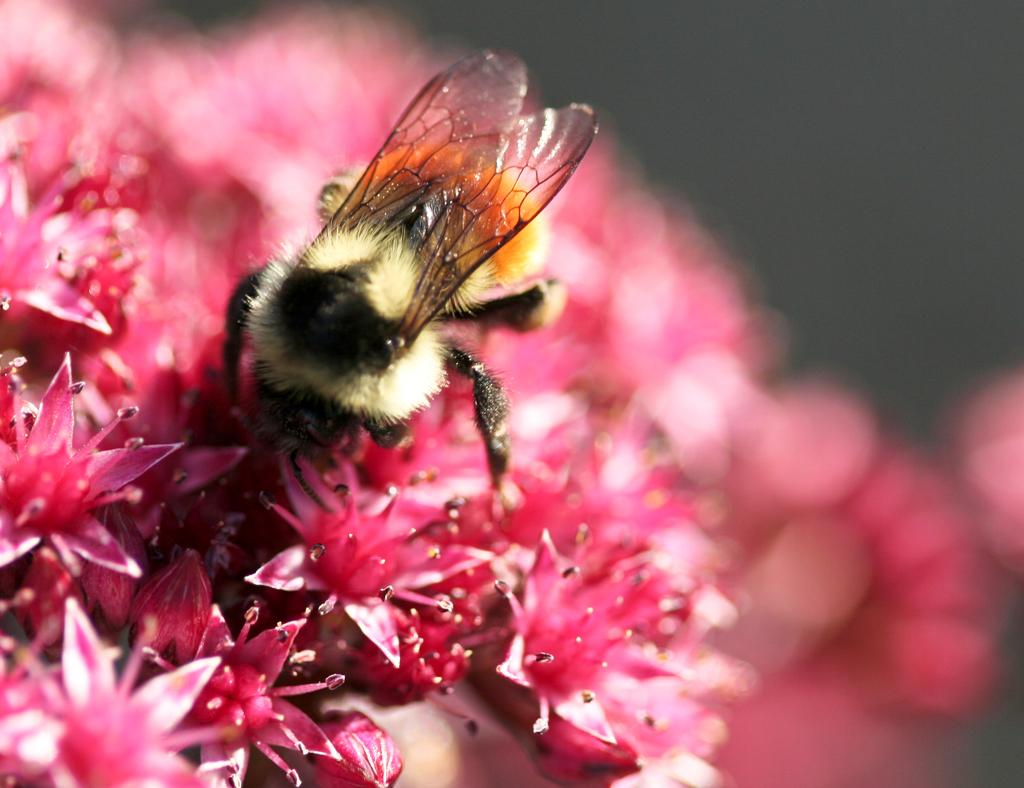What is the main subject of the image? There is an insect in the image. What is the insect's location in the image? The insect is on pink color flowers. Can you describe the quality of the image? The image is blurry at the back. How many steps does the insect need to reach the seat in the image? There is no seat present in the image, so the insect does not need to take any steps to reach it. 